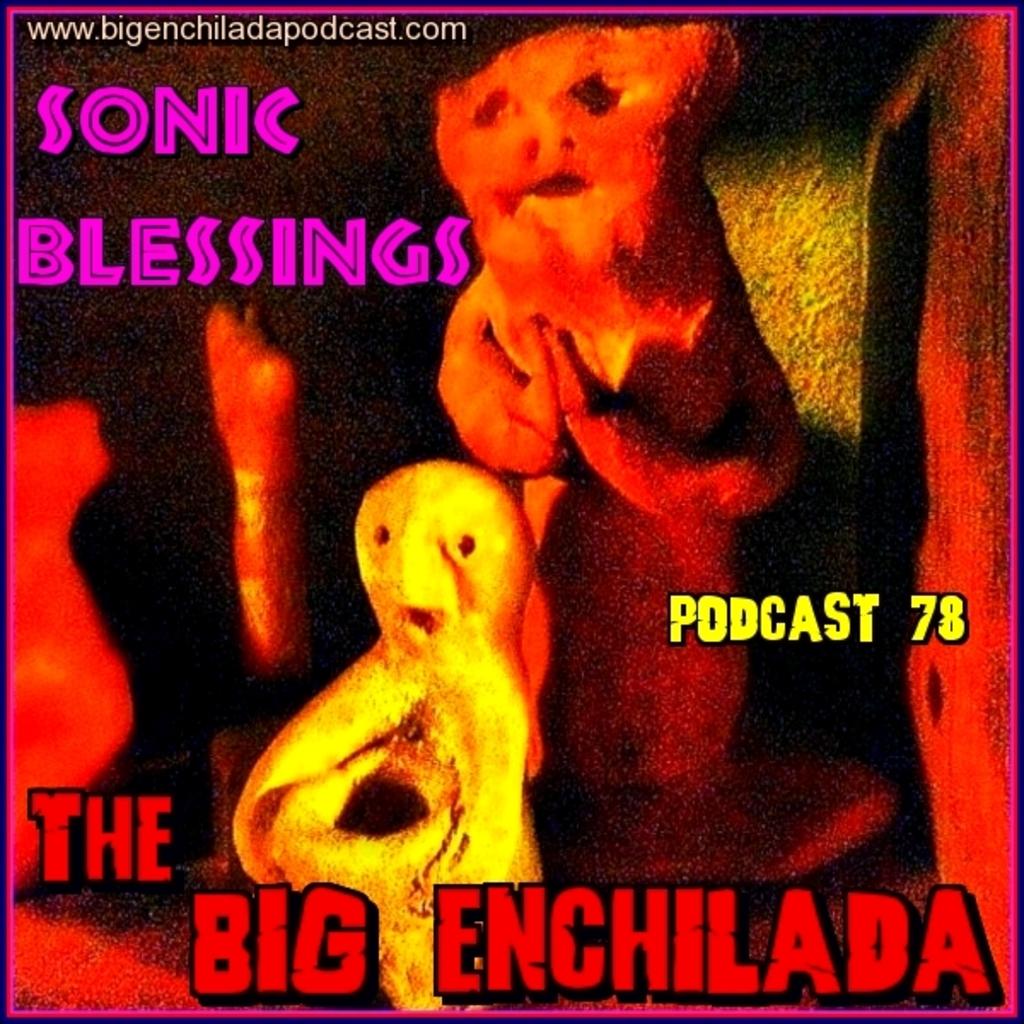What number is the podcast?
Your answer should be very brief. 78. What is the website?
Provide a short and direct response. Www.bigenchiladapodcast.com. 